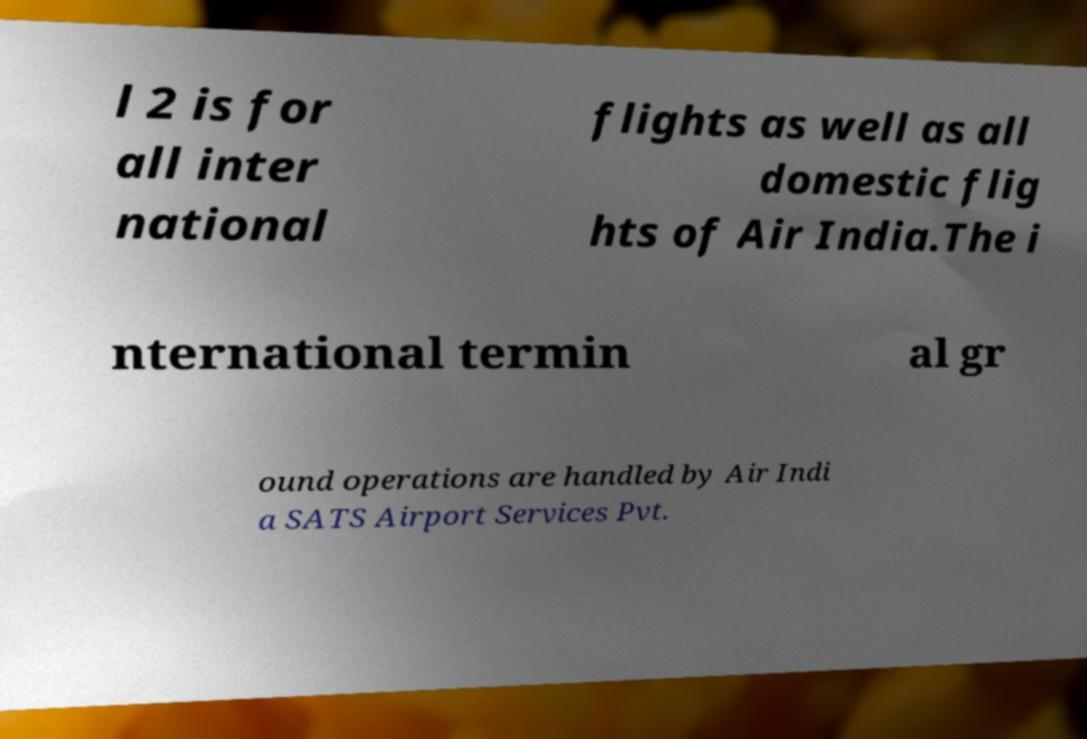Please identify and transcribe the text found in this image. l 2 is for all inter national flights as well as all domestic flig hts of Air India.The i nternational termin al gr ound operations are handled by Air Indi a SATS Airport Services Pvt. 